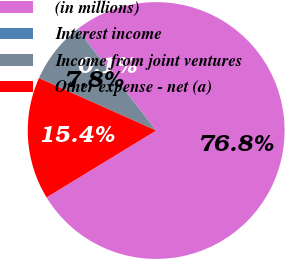Convert chart to OTSL. <chart><loc_0><loc_0><loc_500><loc_500><pie_chart><fcel>(in millions)<fcel>Interest income<fcel>Income from joint ventures<fcel>Other expense - net (a)<nl><fcel>76.76%<fcel>0.08%<fcel>7.75%<fcel>15.41%<nl></chart> 